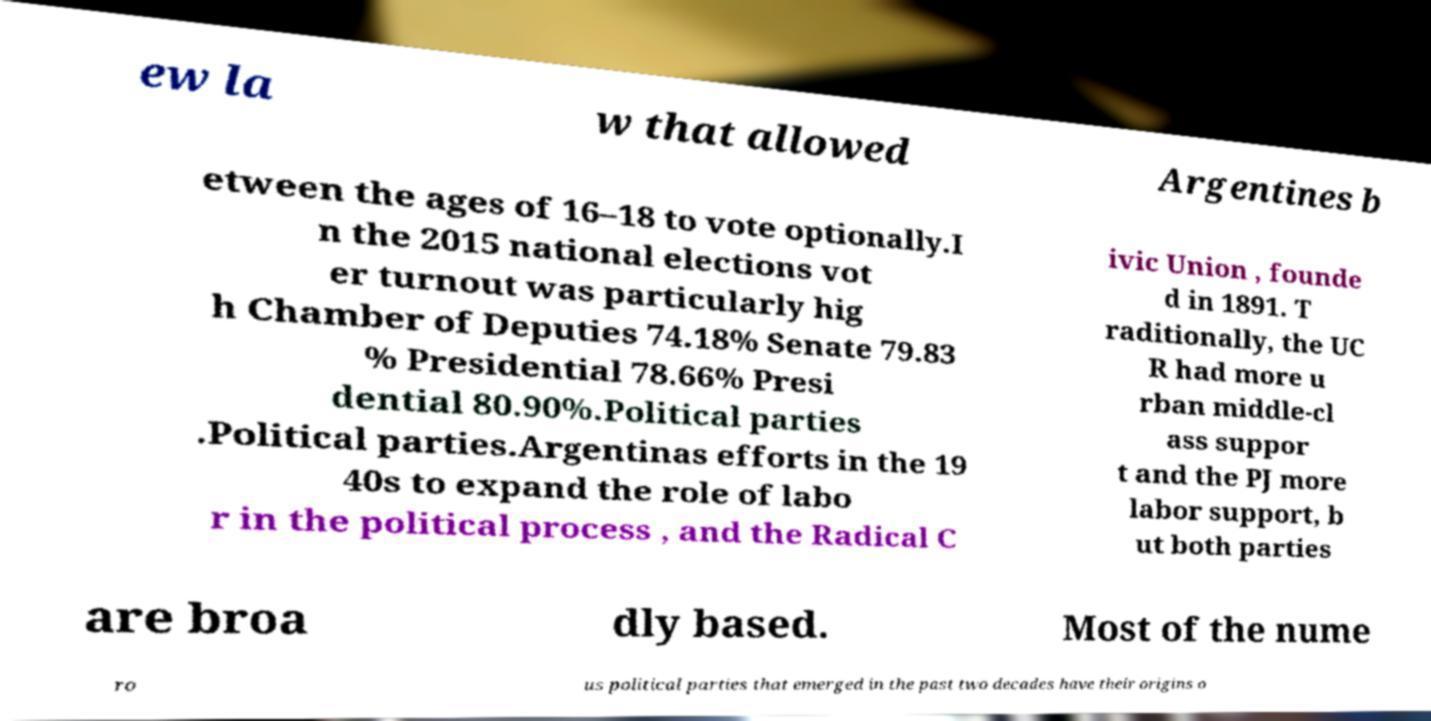For documentation purposes, I need the text within this image transcribed. Could you provide that? ew la w that allowed Argentines b etween the ages of 16–18 to vote optionally.I n the 2015 national elections vot er turnout was particularly hig h Chamber of Deputies 74.18% Senate 79.83 % Presidential 78.66% Presi dential 80.90%.Political parties .Political parties.Argentinas efforts in the 19 40s to expand the role of labo r in the political process , and the Radical C ivic Union , founde d in 1891. T raditionally, the UC R had more u rban middle-cl ass suppor t and the PJ more labor support, b ut both parties are broa dly based. Most of the nume ro us political parties that emerged in the past two decades have their origins o 